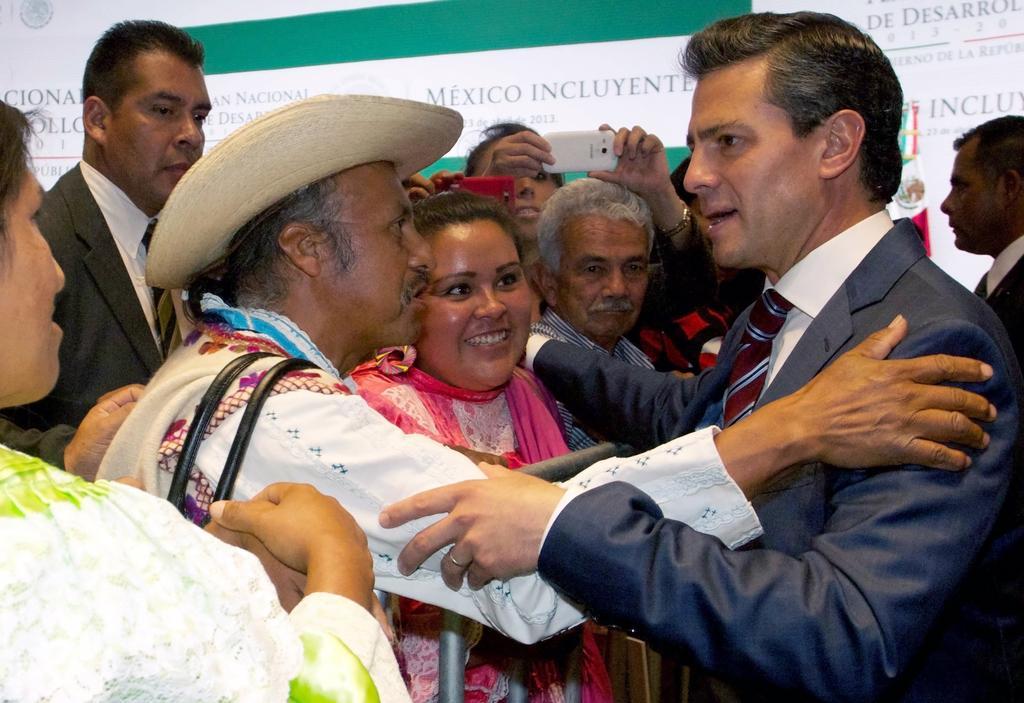Please provide a concise description of this image. In this image there are two men who are holding each others hand. In the background there are few people who are taking the pictures with the mobile. Behind them there are banners. 